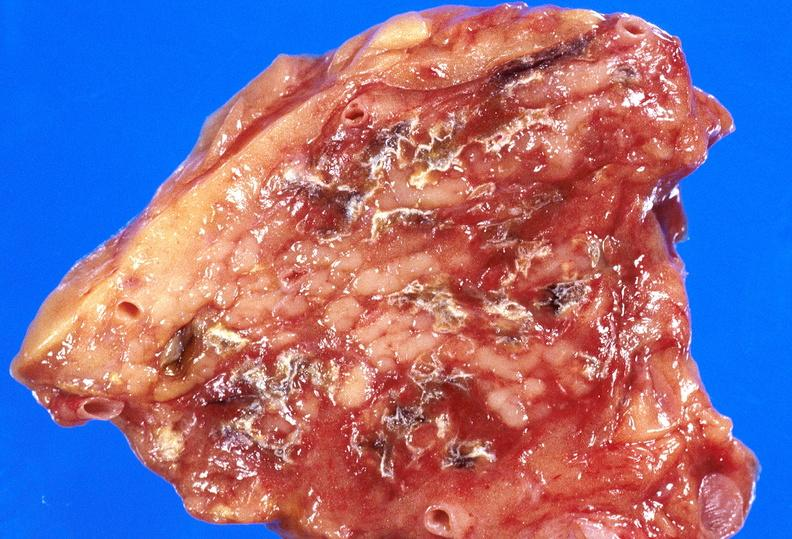does spleen show pancreatic fat necrosis?
Answer the question using a single word or phrase. No 